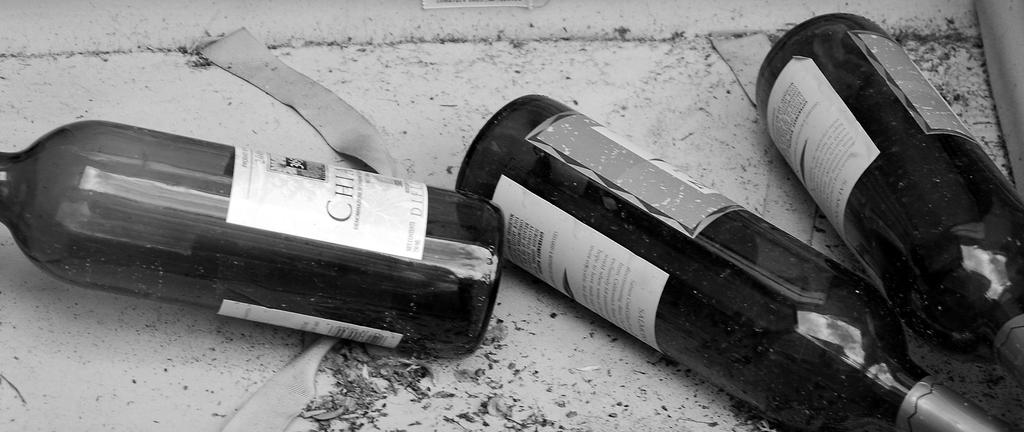How many bottles are on the ground in the image? There are three bottles on the ground in the image. What else can be seen in the image besides the bottles? A belt is visible in the image. What type of amusement can be seen in the image? There is no amusement present in the image; it only features three bottles on the ground and a belt. 